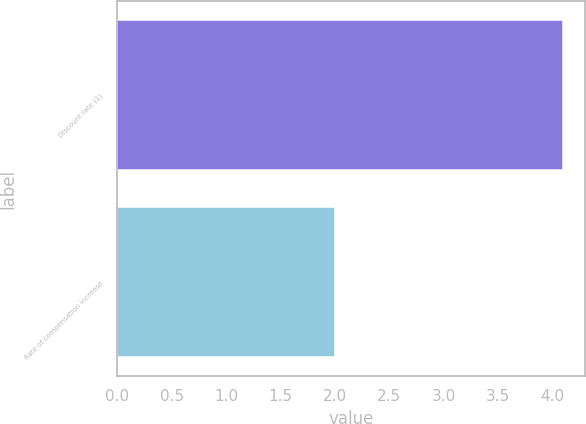<chart> <loc_0><loc_0><loc_500><loc_500><bar_chart><fcel>Discount rate (1)<fcel>Rate of compensation increase<nl><fcel>4.1<fcel>2<nl></chart> 